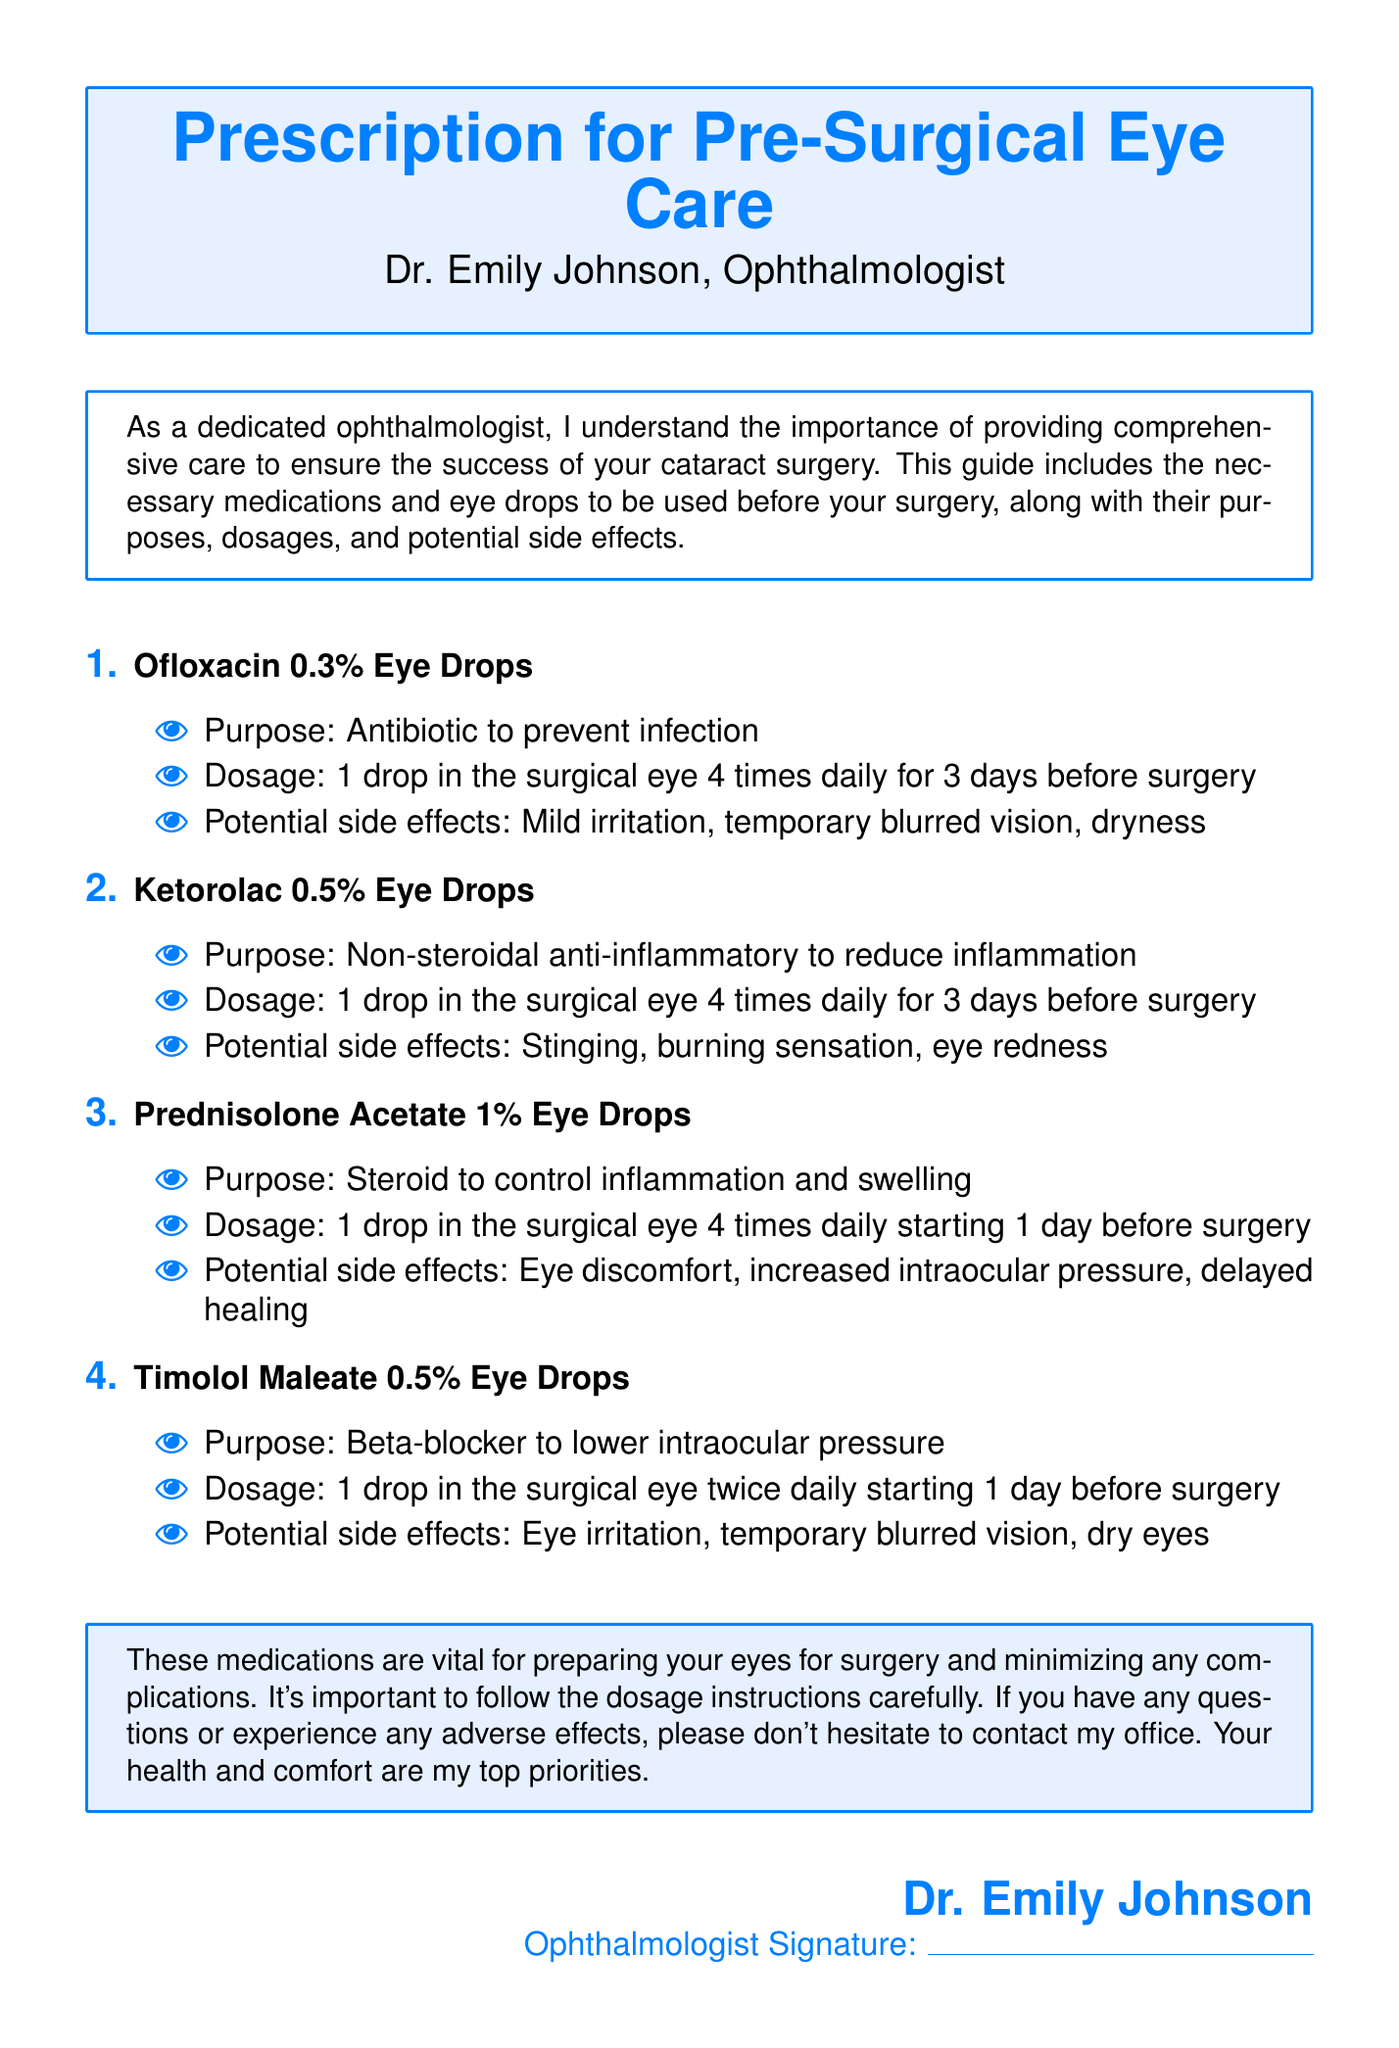what is the title of the document? The title of the document is prominently displayed at the top as the main heading.
Answer: Prescription for Pre-Surgical Eye Care who is the author of the document? The author is mentioned below the title, indicating their profession and role.
Answer: Dr. Emily Johnson how many types of eye drops are prescribed? The document lists various medications, and the total is determined by counting the entries.
Answer: Four what is the purpose of Ofloxacin 0.3% Eye Drops? The document specifies the role of Ofloxacin in preventing infection, highlighting its main function.
Answer: Antibiotic to prevent infection what dosage is recommended for Prednisolone Acetate 1% Eye Drops? The dosage is explicitly stated for Prednisolone in the corresponding section for that medication.
Answer: 1 drop in the surgical eye 4 times daily starting 1 day before surgery what potential side effect is associated with Timolol Maleate 0.5% Eye Drops? The document details possible side effects for each medication, including for Timolol.
Answer: Eye irritation which eye drops should be used 4 times daily? The document outlines the dosages for the medications, indicating which ones require this frequency.
Answer: Ofloxacin 0.3% and Ketorolac 0.5% what should a patient do if they experience adverse effects? The document provides guidance on what to do in case of any issues after using the prescribed medications.
Answer: Contact my office when should Ketorolac 0.5% Eye Drops be started? The timing for starting Ketorolac is specified relative to the surgery schedule in the pertinent section.
Answer: 3 days before surgery 